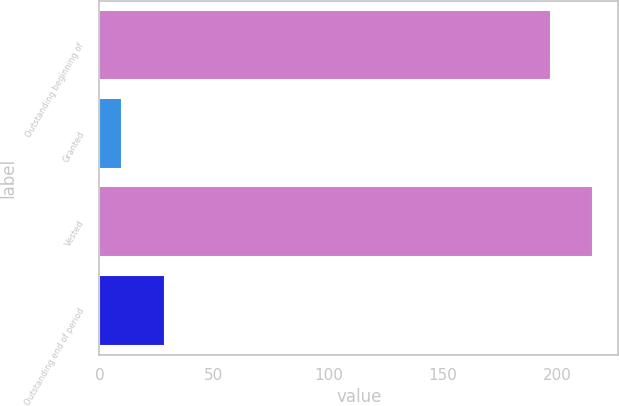Convert chart. <chart><loc_0><loc_0><loc_500><loc_500><bar_chart><fcel>Outstanding beginning of<fcel>Granted<fcel>Vested<fcel>Outstanding end of period<nl><fcel>197<fcel>10<fcel>215.7<fcel>28.7<nl></chart> 